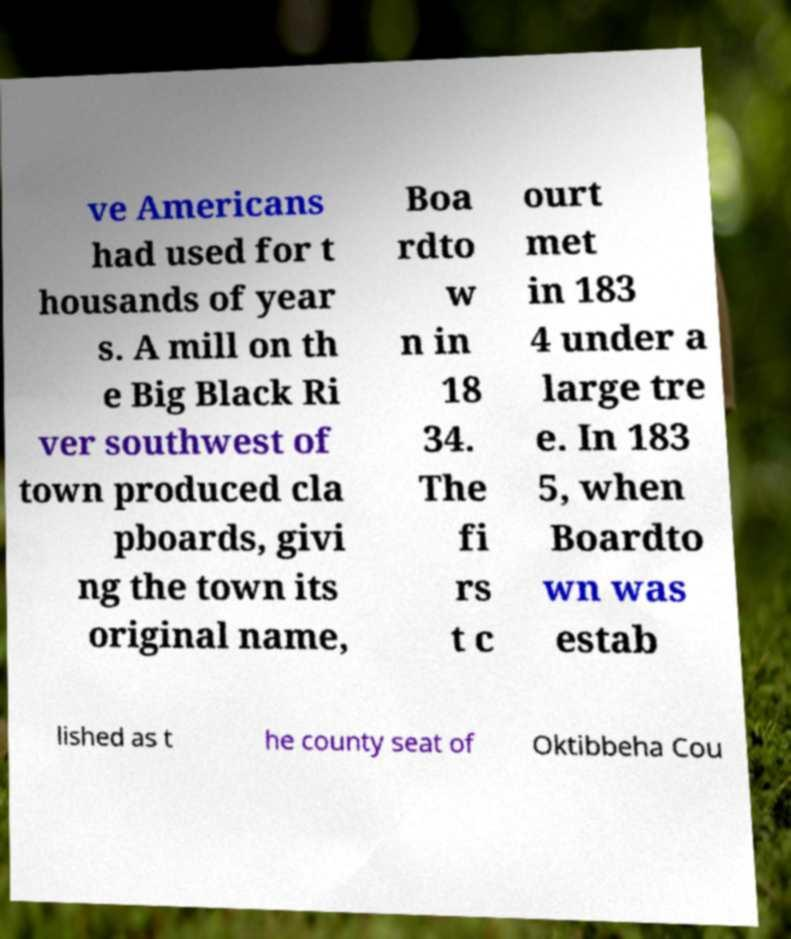There's text embedded in this image that I need extracted. Can you transcribe it verbatim? ve Americans had used for t housands of year s. A mill on th e Big Black Ri ver southwest of town produced cla pboards, givi ng the town its original name, Boa rdto w n in 18 34. The fi rs t c ourt met in 183 4 under a large tre e. In 183 5, when Boardto wn was estab lished as t he county seat of Oktibbeha Cou 